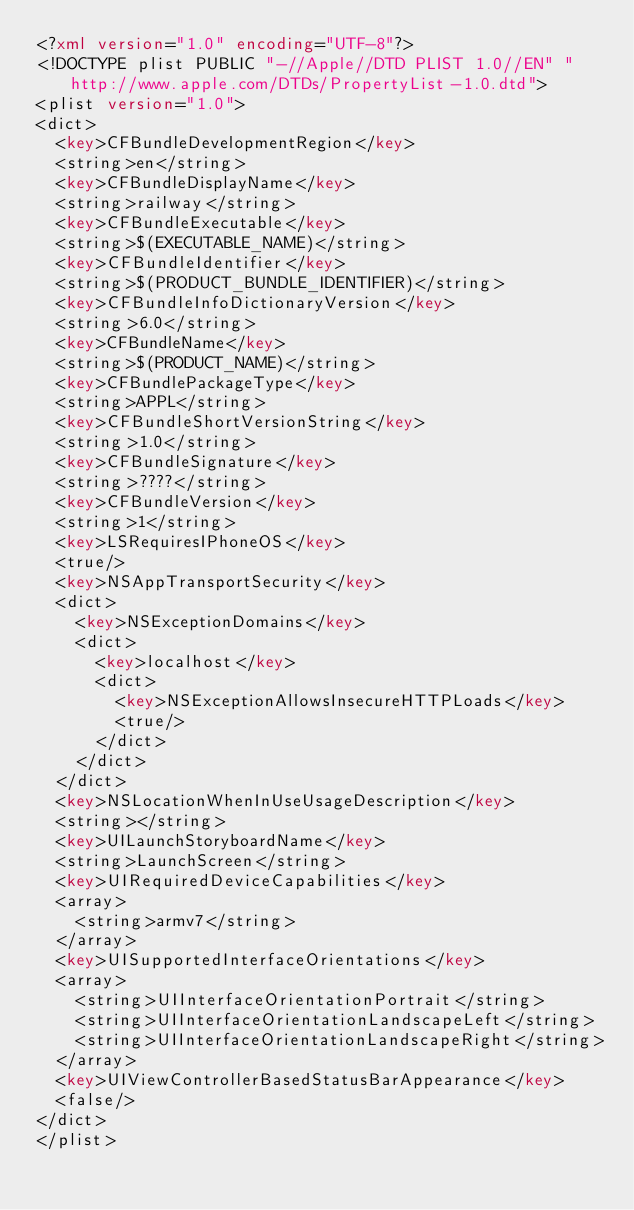<code> <loc_0><loc_0><loc_500><loc_500><_XML_><?xml version="1.0" encoding="UTF-8"?>
<!DOCTYPE plist PUBLIC "-//Apple//DTD PLIST 1.0//EN" "http://www.apple.com/DTDs/PropertyList-1.0.dtd">
<plist version="1.0">
<dict>
	<key>CFBundleDevelopmentRegion</key>
	<string>en</string>
	<key>CFBundleDisplayName</key>
	<string>railway</string>
	<key>CFBundleExecutable</key>
	<string>$(EXECUTABLE_NAME)</string>
	<key>CFBundleIdentifier</key>
	<string>$(PRODUCT_BUNDLE_IDENTIFIER)</string>
	<key>CFBundleInfoDictionaryVersion</key>
	<string>6.0</string>
	<key>CFBundleName</key>
	<string>$(PRODUCT_NAME)</string>
	<key>CFBundlePackageType</key>
	<string>APPL</string>
	<key>CFBundleShortVersionString</key>
	<string>1.0</string>
	<key>CFBundleSignature</key>
	<string>????</string>
	<key>CFBundleVersion</key>
	<string>1</string>
	<key>LSRequiresIPhoneOS</key>
	<true/>
	<key>NSAppTransportSecurity</key>
	<dict>
		<key>NSExceptionDomains</key>
		<dict>
			<key>localhost</key>
			<dict>
				<key>NSExceptionAllowsInsecureHTTPLoads</key>
				<true/>
			</dict>
		</dict>
	</dict>
	<key>NSLocationWhenInUseUsageDescription</key>
	<string></string>
	<key>UILaunchStoryboardName</key>
	<string>LaunchScreen</string>
	<key>UIRequiredDeviceCapabilities</key>
	<array>
		<string>armv7</string>
	</array>
	<key>UISupportedInterfaceOrientations</key>
	<array>
		<string>UIInterfaceOrientationPortrait</string>
		<string>UIInterfaceOrientationLandscapeLeft</string>
		<string>UIInterfaceOrientationLandscapeRight</string>
	</array>
	<key>UIViewControllerBasedStatusBarAppearance</key>
	<false/>
</dict>
</plist>
</code> 